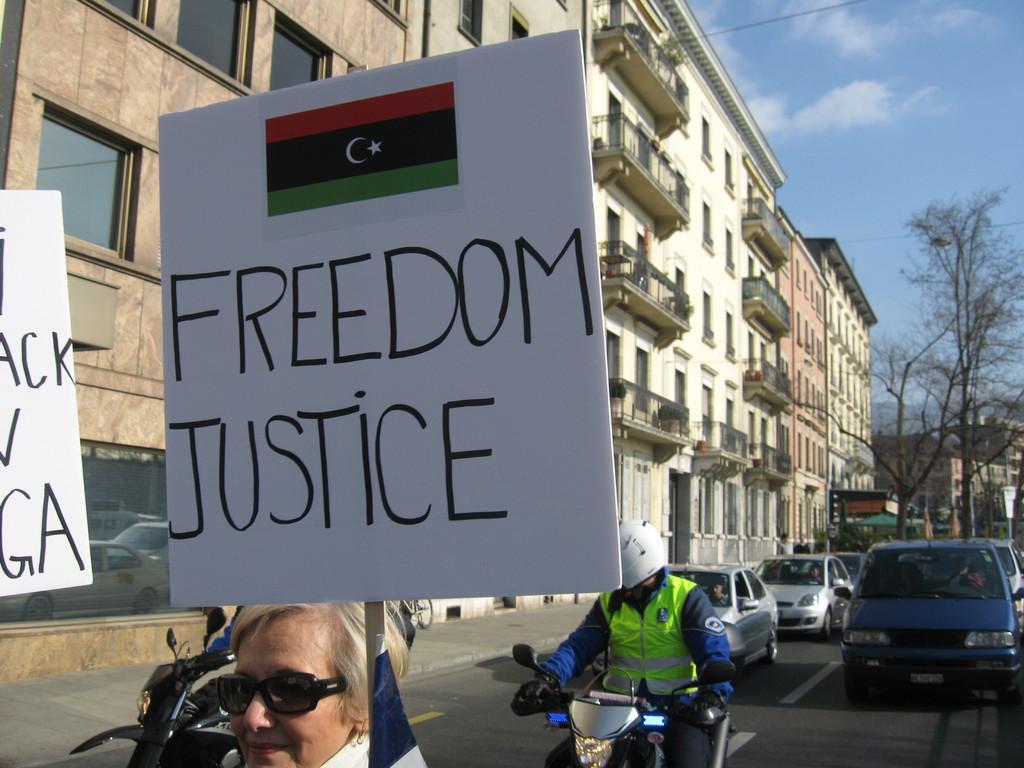How would you summarize this image in a sentence or two? In the middle of the image there is a lady with goggles and she is holding a placard in her hand. And on the left corner of the image there is a placard. Behind the lady on the road there are few vehicles. And also there are buildings with walls, windows and railings. In the top right corner of the image there is sky. And also there are trees. 